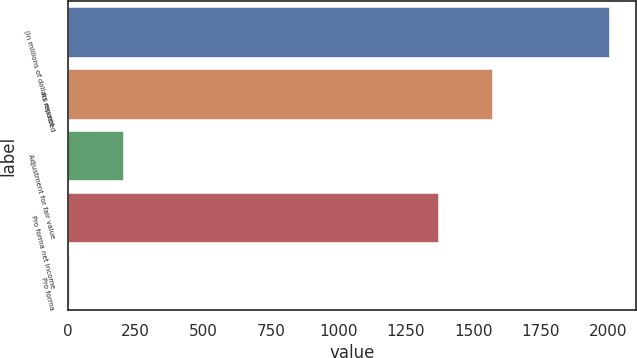Convert chart. <chart><loc_0><loc_0><loc_500><loc_500><bar_chart><fcel>(In millions of dollars except<fcel>As reported<fcel>Adjustment for fair value<fcel>Pro forma net income<fcel>Pro forma<nl><fcel>2003<fcel>1569.04<fcel>202.61<fcel>1369<fcel>2.57<nl></chart> 